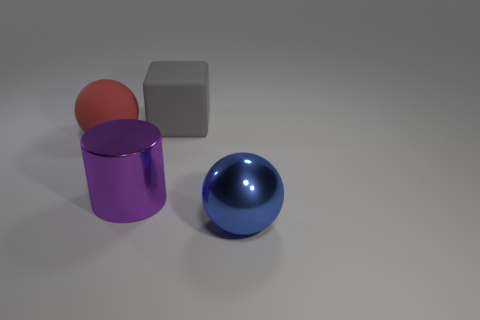Add 2 big shiny objects. How many objects exist? 6 Subtract all cubes. How many objects are left? 3 Add 2 big matte things. How many big matte things are left? 4 Add 1 large gray things. How many large gray things exist? 2 Subtract 1 gray cubes. How many objects are left? 3 Subtract all brown cylinders. Subtract all purple metallic objects. How many objects are left? 3 